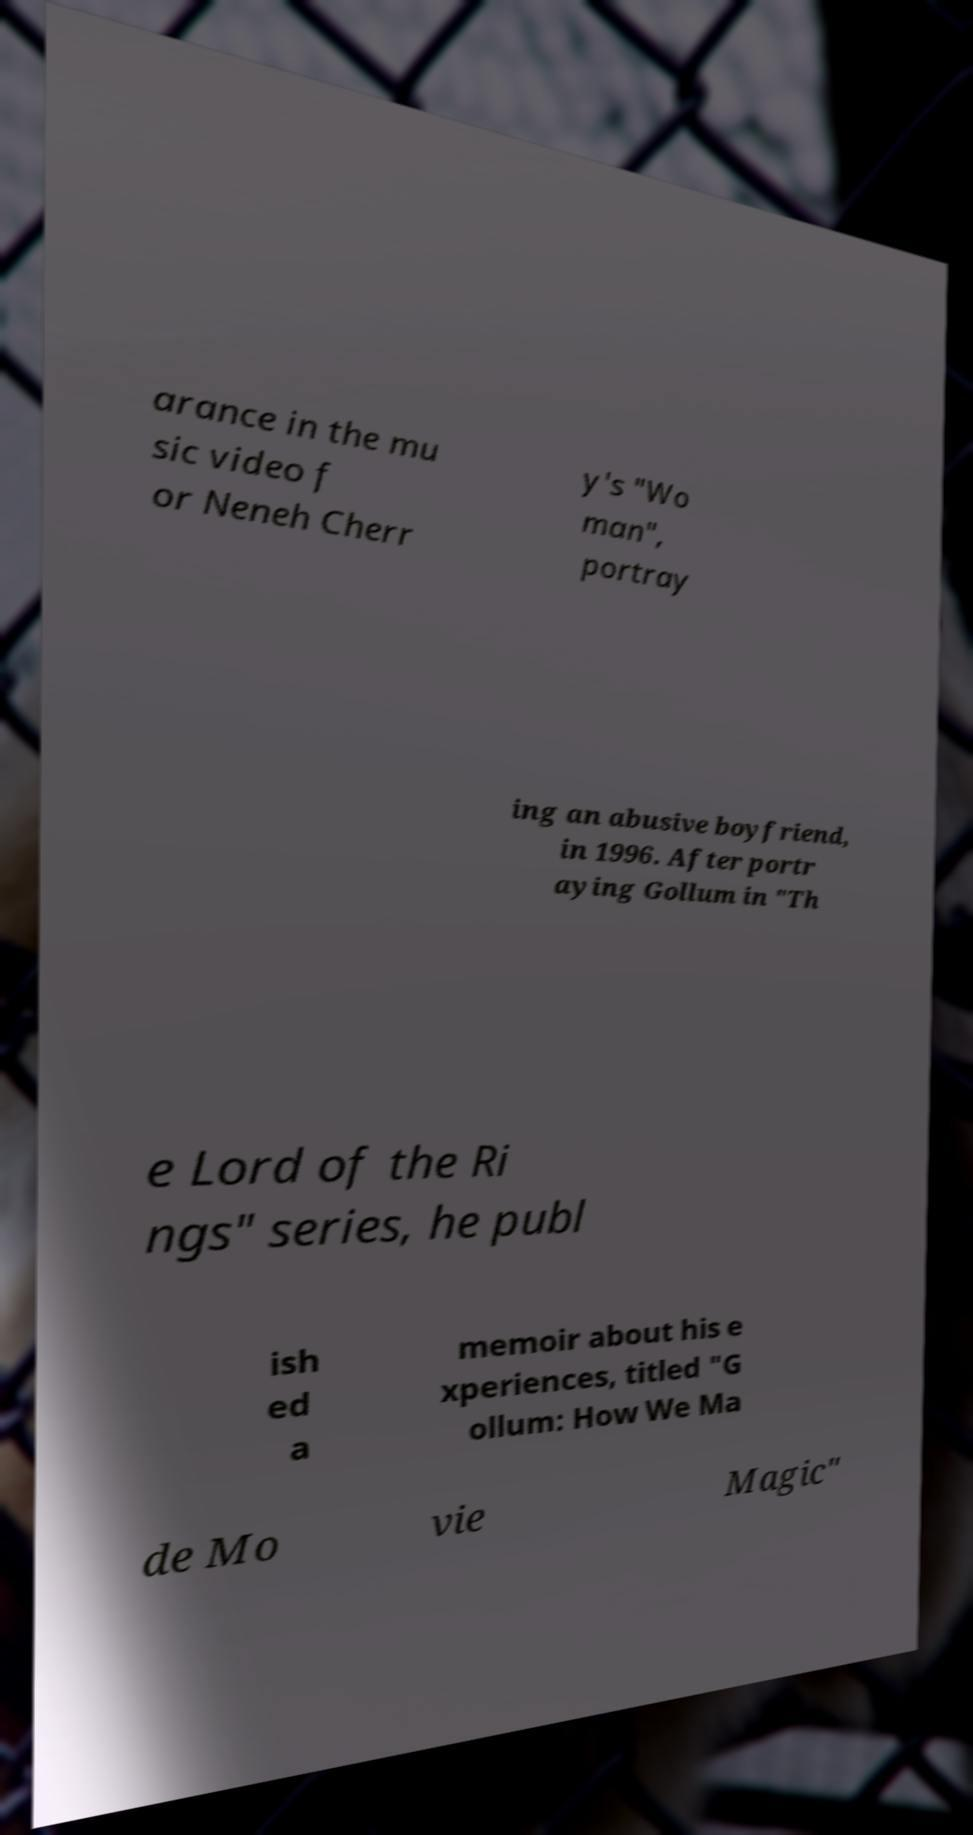Can you accurately transcribe the text from the provided image for me? arance in the mu sic video f or Neneh Cherr y's "Wo man", portray ing an abusive boyfriend, in 1996. After portr aying Gollum in "Th e Lord of the Ri ngs" series, he publ ish ed a memoir about his e xperiences, titled "G ollum: How We Ma de Mo vie Magic" 